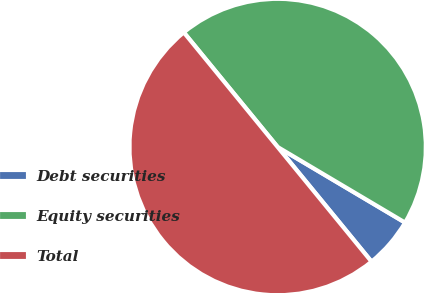Convert chart. <chart><loc_0><loc_0><loc_500><loc_500><pie_chart><fcel>Debt securities<fcel>Equity securities<fcel>Total<nl><fcel>5.56%<fcel>44.44%<fcel>50.0%<nl></chart> 